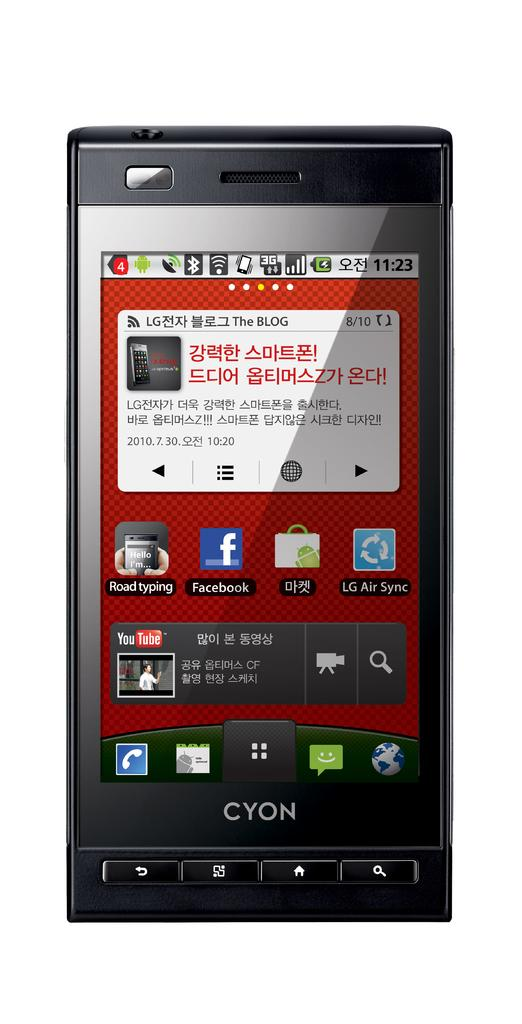<image>
Describe the image concisely. A Cyon phone says "the blog" near the top of the screen. 